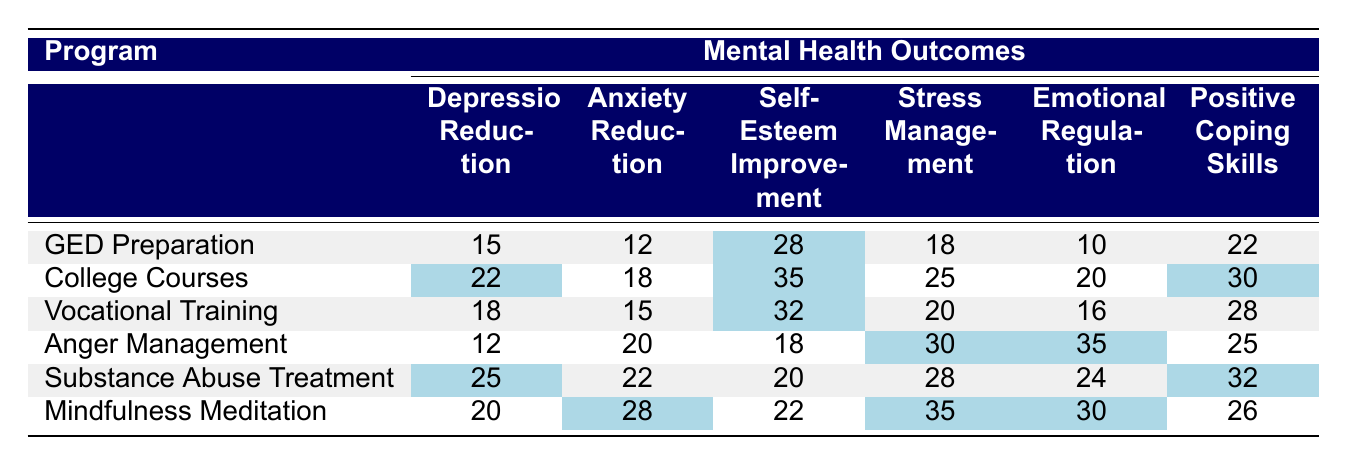What program has the highest score in Self-Esteem Improvement? By reviewing the "Self-Esteem Improvement" column, we see that "College Courses" has the highest score of 35.
Answer: College Courses Which program shows the greatest reduction in Anxiety? Looking at the "Anxiety Reduction" column, "Mindfulness Meditation" has the highest score of 28.
Answer: Mindfulness Meditation What is the average score for Depression Reduction across all programs? The scores for Depression Reduction are 15, 22, 18, 12, 25, and 20. The sum is 112, and dividing by 6 gives an average of 18.67.
Answer: 18.67 Is "Anger Management" more effective in Emotional Regulation than "Vocational Training"? "Anger Management" has a score of 35 in Emotional Regulation, while "Vocational Training" has a score of 16. Therefore, yes, it is more effective.
Answer: Yes What is the difference in scores for Stress Management between "Substance Abuse Treatment" and "College Courses"? "Substance Abuse Treatment" scores 28 and "College Courses" scores 25. The difference is 28 - 25 = 3.
Answer: 3 Which program has the lowest overall mental health outcome scores? Summing up each program's scores, "Anger Management" has a total score of 105, which is the lowest total compared to others.
Answer: Anger Management What is the total score for "Mindfulness Meditation"? Adding up the scores: 20 (Depression) + 28 (Anxiety) + 22 (Self-Esteem) + 35 (Stress) + 30 (Emotional) + 26 (Coping) gives a total of 161.
Answer: 161 Which two programs have the highest combined scores for Positive Coping Skills? The top scores for Positive Coping Skills are 30 (College Courses) and 32 (Substance Abuse Treatment), resulting in a combined score of 62.
Answer: 62 What percentage of the total scores in Emotional Regulation is attributed to "Substance Abuse Treatment"? First, the total score for Emotional Regulation is 10 + 20 + 16 + 35 + 24 + 30 = 135. "Substance Abuse Treatment" has 24, which is (24/135) * 100 ≈ 17.78%.
Answer: 17.78% Which program has the most balanced scores across all mental health outcomes? Observing the range of scores, "College Courses" shows consistent performance across all areas, with scores ranging from 18 to 35, indicating a balanced impact.
Answer: College Courses 